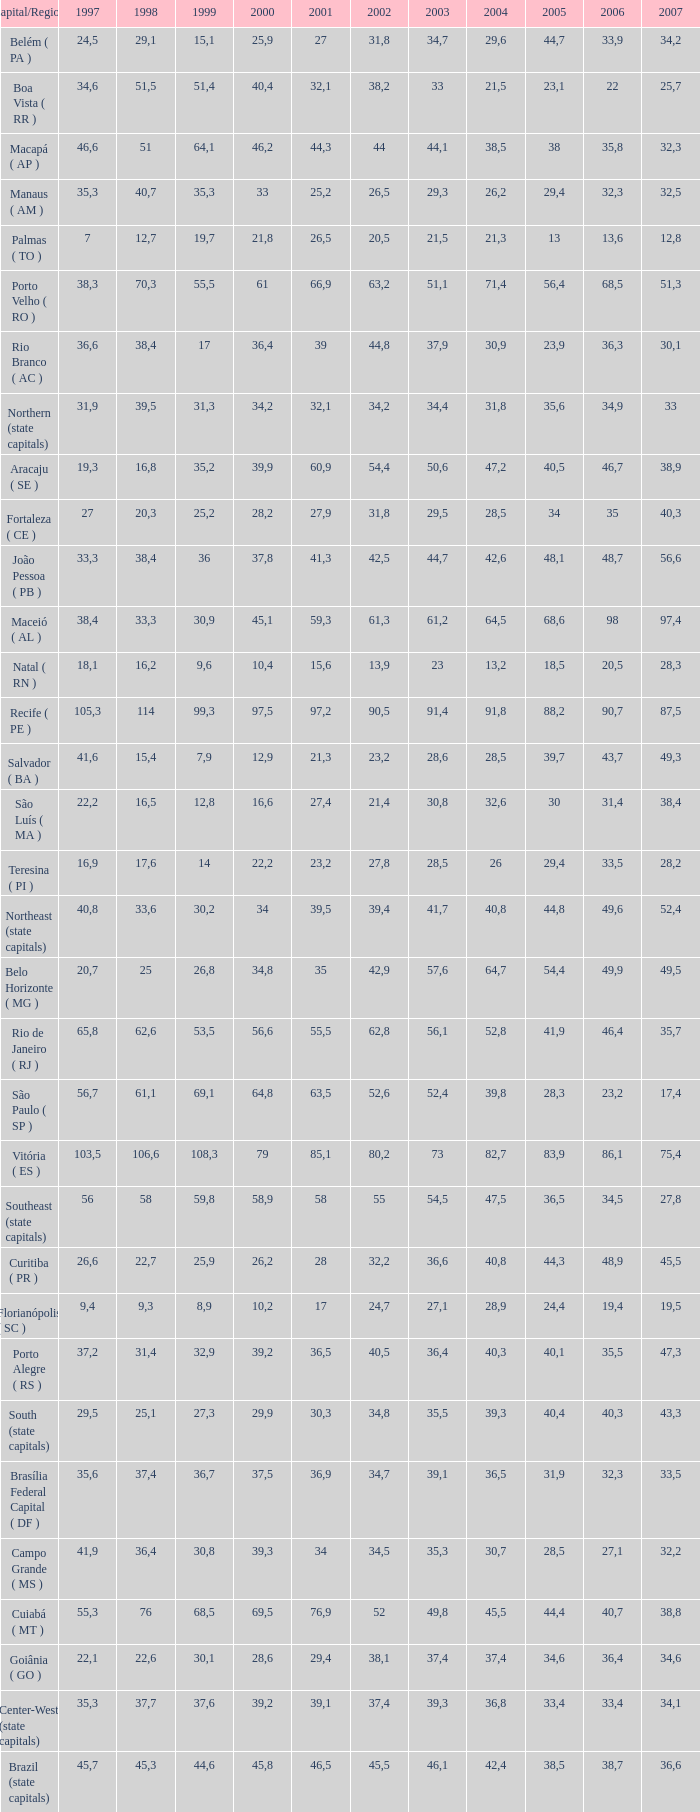In how many cases does a 2007 have a 2003 lower than 36.4, a 2001 equal to 27.9, and a 1999 below 25.2? None. 